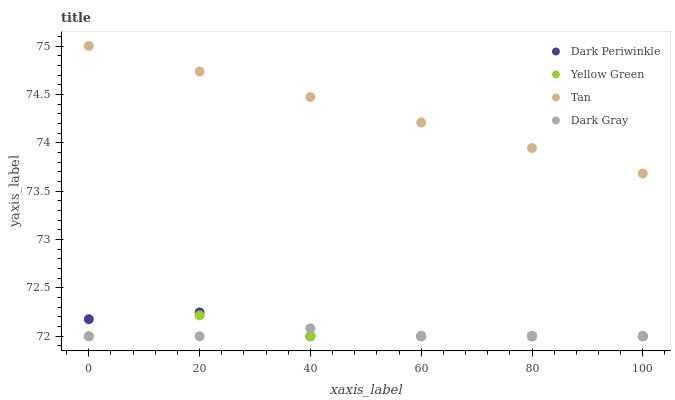Does Dark Gray have the minimum area under the curve?
Answer yes or no. Yes. Does Tan have the maximum area under the curve?
Answer yes or no. Yes. Does Dark Periwinkle have the minimum area under the curve?
Answer yes or no. No. Does Dark Periwinkle have the maximum area under the curve?
Answer yes or no. No. Is Tan the smoothest?
Answer yes or no. Yes. Is Yellow Green the roughest?
Answer yes or no. Yes. Is Dark Periwinkle the smoothest?
Answer yes or no. No. Is Dark Periwinkle the roughest?
Answer yes or no. No. Does Dark Gray have the lowest value?
Answer yes or no. Yes. Does Tan have the lowest value?
Answer yes or no. No. Does Tan have the highest value?
Answer yes or no. Yes. Does Dark Periwinkle have the highest value?
Answer yes or no. No. Is Yellow Green less than Tan?
Answer yes or no. Yes. Is Tan greater than Dark Gray?
Answer yes or no. Yes. Does Dark Gray intersect Dark Periwinkle?
Answer yes or no. Yes. Is Dark Gray less than Dark Periwinkle?
Answer yes or no. No. Is Dark Gray greater than Dark Periwinkle?
Answer yes or no. No. Does Yellow Green intersect Tan?
Answer yes or no. No. 